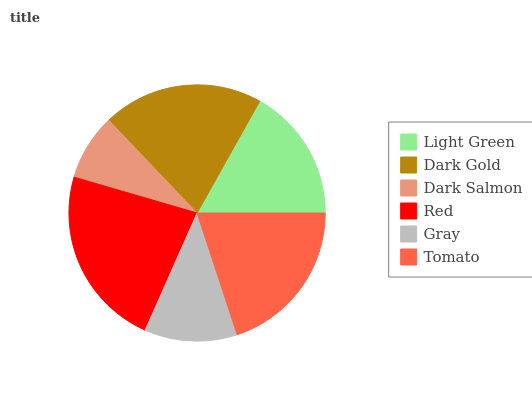Is Dark Salmon the minimum?
Answer yes or no. Yes. Is Red the maximum?
Answer yes or no. Yes. Is Dark Gold the minimum?
Answer yes or no. No. Is Dark Gold the maximum?
Answer yes or no. No. Is Dark Gold greater than Light Green?
Answer yes or no. Yes. Is Light Green less than Dark Gold?
Answer yes or no. Yes. Is Light Green greater than Dark Gold?
Answer yes or no. No. Is Dark Gold less than Light Green?
Answer yes or no. No. Is Tomato the high median?
Answer yes or no. Yes. Is Light Green the low median?
Answer yes or no. Yes. Is Light Green the high median?
Answer yes or no. No. Is Dark Salmon the low median?
Answer yes or no. No. 